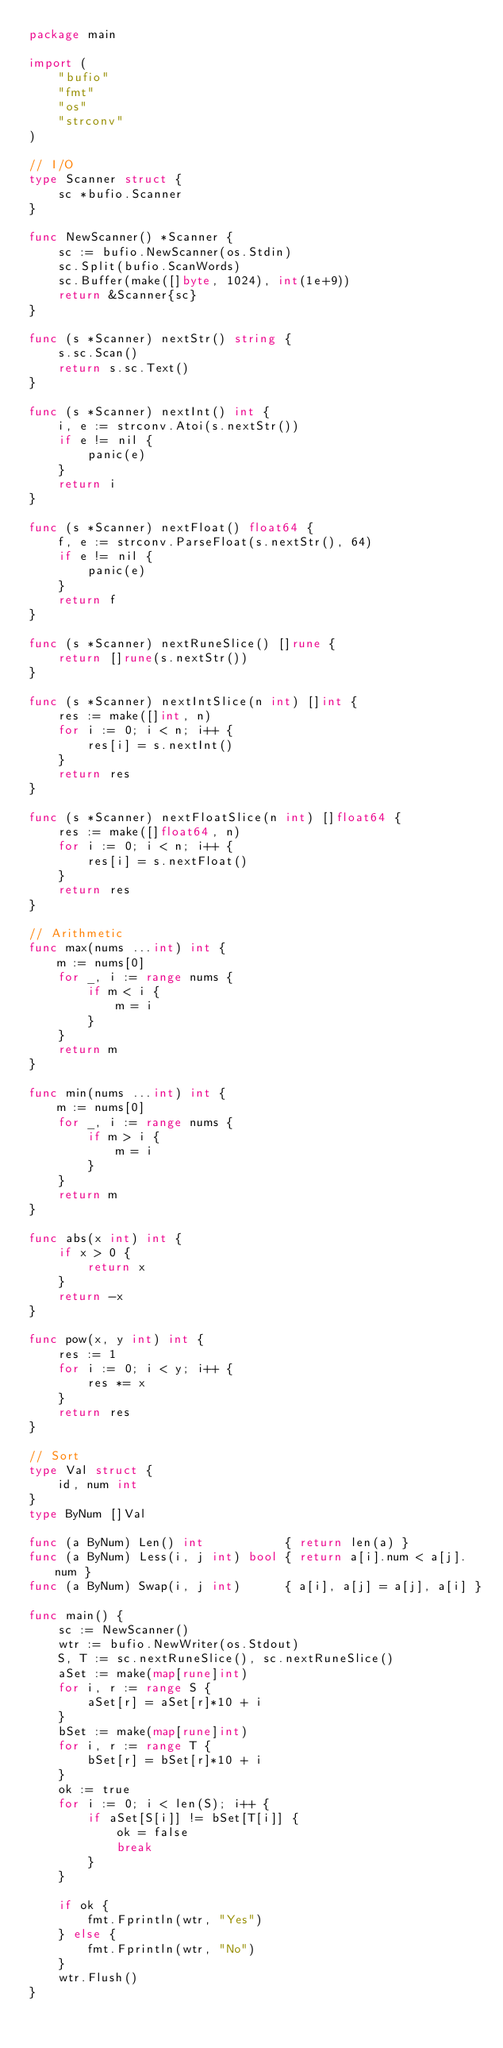Convert code to text. <code><loc_0><loc_0><loc_500><loc_500><_Go_>package main

import (
	"bufio"
	"fmt"
	"os"
	"strconv"
)

// I/O
type Scanner struct {
	sc *bufio.Scanner
}

func NewScanner() *Scanner {
	sc := bufio.NewScanner(os.Stdin)
	sc.Split(bufio.ScanWords)
	sc.Buffer(make([]byte, 1024), int(1e+9))
	return &Scanner{sc}
}

func (s *Scanner) nextStr() string {
	s.sc.Scan()
	return s.sc.Text()
}

func (s *Scanner) nextInt() int {
	i, e := strconv.Atoi(s.nextStr())
	if e != nil {
		panic(e)
	}
	return i
}

func (s *Scanner) nextFloat() float64 {
	f, e := strconv.ParseFloat(s.nextStr(), 64)
	if e != nil {
		panic(e)
	}
	return f
}

func (s *Scanner) nextRuneSlice() []rune {
	return []rune(s.nextStr())
}

func (s *Scanner) nextIntSlice(n int) []int {
	res := make([]int, n)
	for i := 0; i < n; i++ {
		res[i] = s.nextInt()
	}
	return res
}

func (s *Scanner) nextFloatSlice(n int) []float64 {
	res := make([]float64, n)
	for i := 0; i < n; i++ {
		res[i] = s.nextFloat()
	}
	return res
}

// Arithmetic
func max(nums ...int) int {
	m := nums[0]
	for _, i := range nums {
		if m < i {
			m = i
		}
	}
	return m
}

func min(nums ...int) int {
	m := nums[0]
	for _, i := range nums {
		if m > i {
			m = i
		}
	}
	return m
}

func abs(x int) int {
	if x > 0 {
		return x
	}
	return -x
}

func pow(x, y int) int {
	res := 1
	for i := 0; i < y; i++ {
		res *= x
	}
	return res
}

// Sort
type Val struct {
	id, num int
}
type ByNum []Val

func (a ByNum) Len() int           { return len(a) }
func (a ByNum) Less(i, j int) bool { return a[i].num < a[j].num }
func (a ByNum) Swap(i, j int)      { a[i], a[j] = a[j], a[i] }

func main() {
	sc := NewScanner()
	wtr := bufio.NewWriter(os.Stdout)
	S, T := sc.nextRuneSlice(), sc.nextRuneSlice()
	aSet := make(map[rune]int)
	for i, r := range S {
		aSet[r] = aSet[r]*10 + i
	}
	bSet := make(map[rune]int)
	for i, r := range T {
		bSet[r] = bSet[r]*10 + i
	}
	ok := true
	for i := 0; i < len(S); i++ {
		if aSet[S[i]] != bSet[T[i]] {
			ok = false
			break
		}
	}

	if ok {
		fmt.Fprintln(wtr, "Yes")
	} else {
		fmt.Fprintln(wtr, "No")
	}
	wtr.Flush()
}
</code> 